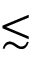Convert formula to latex. <formula><loc_0><loc_0><loc_500><loc_500>\lesssim</formula> 